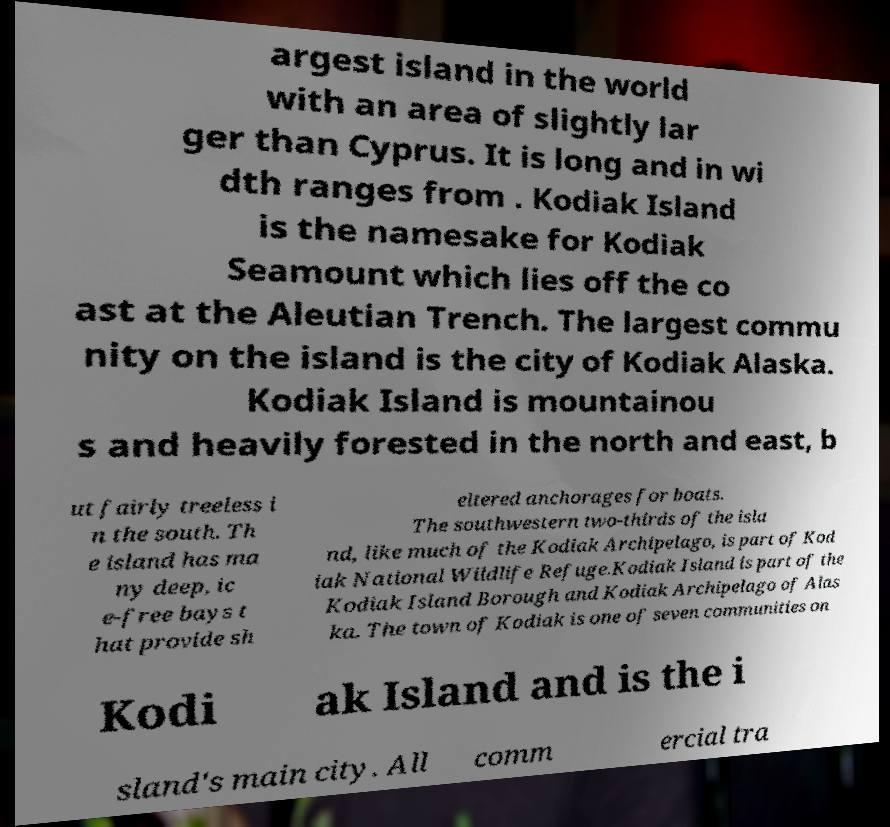For documentation purposes, I need the text within this image transcribed. Could you provide that? argest island in the world with an area of slightly lar ger than Cyprus. It is long and in wi dth ranges from . Kodiak Island is the namesake for Kodiak Seamount which lies off the co ast at the Aleutian Trench. The largest commu nity on the island is the city of Kodiak Alaska. Kodiak Island is mountainou s and heavily forested in the north and east, b ut fairly treeless i n the south. Th e island has ma ny deep, ic e-free bays t hat provide sh eltered anchorages for boats. The southwestern two-thirds of the isla nd, like much of the Kodiak Archipelago, is part of Kod iak National Wildlife Refuge.Kodiak Island is part of the Kodiak Island Borough and Kodiak Archipelago of Alas ka. The town of Kodiak is one of seven communities on Kodi ak Island and is the i sland's main city. All comm ercial tra 